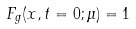Convert formula to latex. <formula><loc_0><loc_0><loc_500><loc_500>F _ { g } ( x , t = 0 ; \mu ) = 1</formula> 